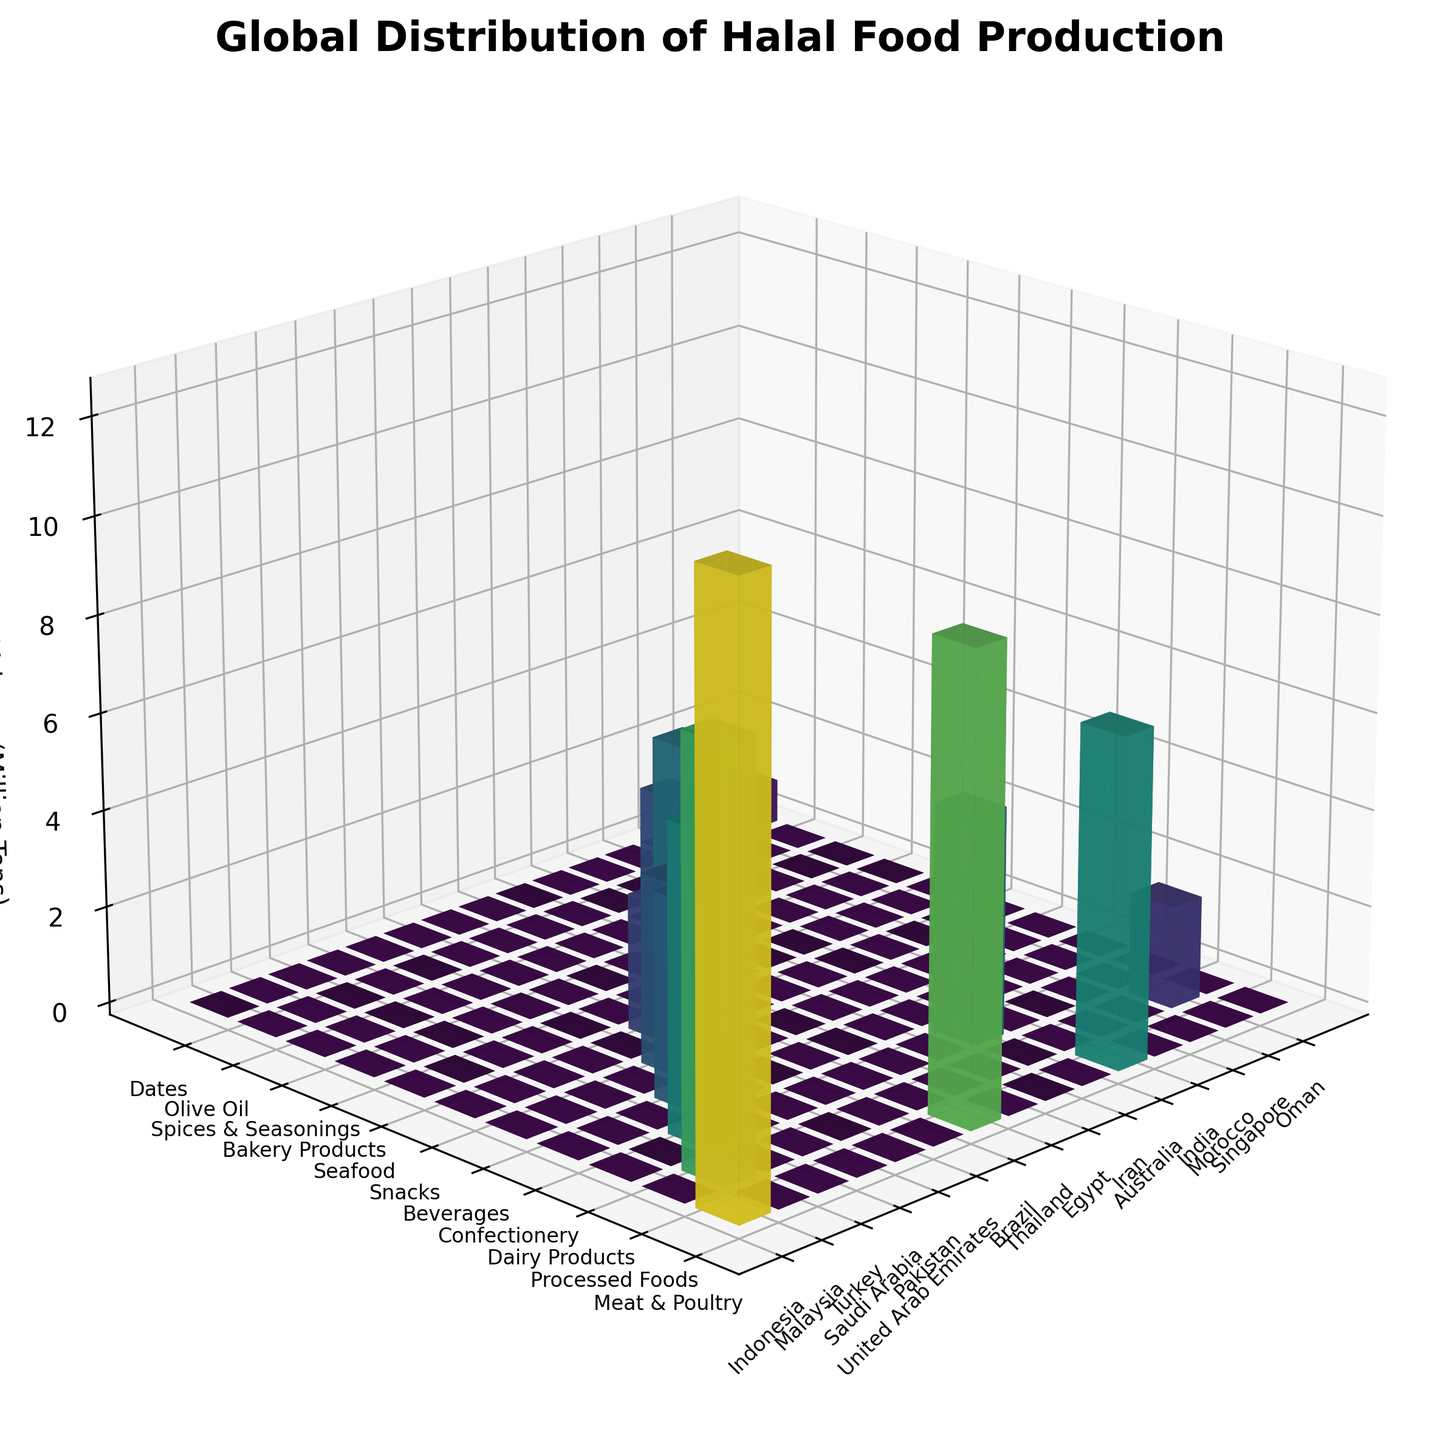What's the title of the figure? The title is generally located at the top of the figure.
Answer: 'Global Distribution of Halal Food Production' What does the z-axis represent? The z-axis typically represents the variable being measured or the output in a bar chart. Here, it shows the 'Production Volume (Million Tons)'.
Answer: 'Production Volume (Million Tons)' How many countries are included in this figure? Count the number of unique countries marked on the x-axis.
Answer: 15 Which country has the highest production volume in the 'Meat & Poultry' category? Compare the heights of the bars associated with the 'Meat & Poultry' category for each country. The highest bar represents the maximum production.
Answer: Indonesia Which product category has the lowest production volume and in which country? Look for the shortest bar in the figure.
Answer: 'Dates' in Oman Which country has the highest production volume overall? Identify the country with the tallest bars across all product categories combined. Sum the production volumes for each country.
Answer: Indonesia What is the difference in production volume of 'Meat & Poultry' between Brazil and Australia? Subtract the production volume of 'Meat & Poultry' in Australia from that in Brazil.
Answer: 2.8 Million Tons What is the combined production volume for 'Dairy Products' across all countries? Add up the production volumes of 'Dairy Products' for Turkey and Iran.
Answer: 11 Million Tons Which country produces the highest volume of 'Processed Foods'? Compare the bars of the 'Processed Foods' category to identify the tallest one.
Answer: Malaysia How does the production volume of 'Snacks' in the United Arab Emirates compare to 'Olive Oil' production in Morocco? Compare the heights of the respective bars.
Answer: 'Snacks' in UAE is greater 